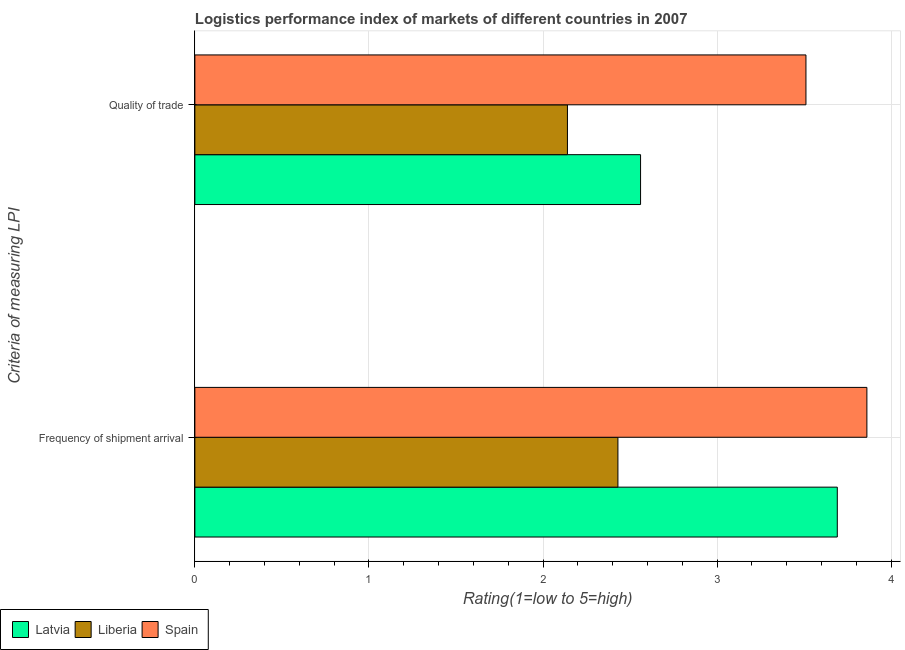How many groups of bars are there?
Keep it short and to the point. 2. Are the number of bars per tick equal to the number of legend labels?
Provide a succinct answer. Yes. Are the number of bars on each tick of the Y-axis equal?
Ensure brevity in your answer.  Yes. How many bars are there on the 1st tick from the bottom?
Make the answer very short. 3. What is the label of the 1st group of bars from the top?
Provide a succinct answer. Quality of trade. What is the lpi quality of trade in Liberia?
Ensure brevity in your answer.  2.14. Across all countries, what is the maximum lpi quality of trade?
Offer a terse response. 3.51. Across all countries, what is the minimum lpi quality of trade?
Provide a short and direct response. 2.14. In which country was the lpi of frequency of shipment arrival minimum?
Provide a short and direct response. Liberia. What is the total lpi of frequency of shipment arrival in the graph?
Make the answer very short. 9.98. What is the difference between the lpi of frequency of shipment arrival in Latvia and that in Spain?
Provide a short and direct response. -0.17. What is the difference between the lpi of frequency of shipment arrival in Latvia and the lpi quality of trade in Spain?
Offer a very short reply. 0.18. What is the average lpi quality of trade per country?
Your answer should be very brief. 2.74. What is the difference between the lpi of frequency of shipment arrival and lpi quality of trade in Spain?
Keep it short and to the point. 0.35. What is the ratio of the lpi quality of trade in Spain to that in Latvia?
Keep it short and to the point. 1.37. What does the 3rd bar from the top in Frequency of shipment arrival represents?
Offer a terse response. Latvia. What does the 3rd bar from the bottom in Quality of trade represents?
Offer a very short reply. Spain. Are all the bars in the graph horizontal?
Your answer should be very brief. Yes. How many countries are there in the graph?
Provide a short and direct response. 3. Are the values on the major ticks of X-axis written in scientific E-notation?
Provide a succinct answer. No. Does the graph contain any zero values?
Keep it short and to the point. No. Does the graph contain grids?
Your answer should be compact. Yes. How many legend labels are there?
Your response must be concise. 3. What is the title of the graph?
Your response must be concise. Logistics performance index of markets of different countries in 2007. What is the label or title of the X-axis?
Offer a very short reply. Rating(1=low to 5=high). What is the label or title of the Y-axis?
Keep it short and to the point. Criteria of measuring LPI. What is the Rating(1=low to 5=high) of Latvia in Frequency of shipment arrival?
Provide a succinct answer. 3.69. What is the Rating(1=low to 5=high) of Liberia in Frequency of shipment arrival?
Offer a very short reply. 2.43. What is the Rating(1=low to 5=high) in Spain in Frequency of shipment arrival?
Offer a terse response. 3.86. What is the Rating(1=low to 5=high) of Latvia in Quality of trade?
Provide a short and direct response. 2.56. What is the Rating(1=low to 5=high) in Liberia in Quality of trade?
Ensure brevity in your answer.  2.14. What is the Rating(1=low to 5=high) in Spain in Quality of trade?
Give a very brief answer. 3.51. Across all Criteria of measuring LPI, what is the maximum Rating(1=low to 5=high) of Latvia?
Your response must be concise. 3.69. Across all Criteria of measuring LPI, what is the maximum Rating(1=low to 5=high) of Liberia?
Your response must be concise. 2.43. Across all Criteria of measuring LPI, what is the maximum Rating(1=low to 5=high) of Spain?
Keep it short and to the point. 3.86. Across all Criteria of measuring LPI, what is the minimum Rating(1=low to 5=high) in Latvia?
Provide a succinct answer. 2.56. Across all Criteria of measuring LPI, what is the minimum Rating(1=low to 5=high) of Liberia?
Your response must be concise. 2.14. Across all Criteria of measuring LPI, what is the minimum Rating(1=low to 5=high) of Spain?
Provide a succinct answer. 3.51. What is the total Rating(1=low to 5=high) in Latvia in the graph?
Give a very brief answer. 6.25. What is the total Rating(1=low to 5=high) in Liberia in the graph?
Give a very brief answer. 4.57. What is the total Rating(1=low to 5=high) in Spain in the graph?
Provide a succinct answer. 7.37. What is the difference between the Rating(1=low to 5=high) of Latvia in Frequency of shipment arrival and that in Quality of trade?
Offer a terse response. 1.13. What is the difference between the Rating(1=low to 5=high) of Liberia in Frequency of shipment arrival and that in Quality of trade?
Your answer should be compact. 0.29. What is the difference between the Rating(1=low to 5=high) in Spain in Frequency of shipment arrival and that in Quality of trade?
Keep it short and to the point. 0.35. What is the difference between the Rating(1=low to 5=high) in Latvia in Frequency of shipment arrival and the Rating(1=low to 5=high) in Liberia in Quality of trade?
Your answer should be compact. 1.55. What is the difference between the Rating(1=low to 5=high) of Latvia in Frequency of shipment arrival and the Rating(1=low to 5=high) of Spain in Quality of trade?
Keep it short and to the point. 0.18. What is the difference between the Rating(1=low to 5=high) in Liberia in Frequency of shipment arrival and the Rating(1=low to 5=high) in Spain in Quality of trade?
Your answer should be very brief. -1.08. What is the average Rating(1=low to 5=high) of Latvia per Criteria of measuring LPI?
Offer a very short reply. 3.12. What is the average Rating(1=low to 5=high) in Liberia per Criteria of measuring LPI?
Provide a succinct answer. 2.29. What is the average Rating(1=low to 5=high) of Spain per Criteria of measuring LPI?
Your answer should be very brief. 3.69. What is the difference between the Rating(1=low to 5=high) of Latvia and Rating(1=low to 5=high) of Liberia in Frequency of shipment arrival?
Provide a succinct answer. 1.26. What is the difference between the Rating(1=low to 5=high) of Latvia and Rating(1=low to 5=high) of Spain in Frequency of shipment arrival?
Keep it short and to the point. -0.17. What is the difference between the Rating(1=low to 5=high) in Liberia and Rating(1=low to 5=high) in Spain in Frequency of shipment arrival?
Provide a succinct answer. -1.43. What is the difference between the Rating(1=low to 5=high) in Latvia and Rating(1=low to 5=high) in Liberia in Quality of trade?
Ensure brevity in your answer.  0.42. What is the difference between the Rating(1=low to 5=high) of Latvia and Rating(1=low to 5=high) of Spain in Quality of trade?
Your answer should be very brief. -0.95. What is the difference between the Rating(1=low to 5=high) in Liberia and Rating(1=low to 5=high) in Spain in Quality of trade?
Provide a short and direct response. -1.37. What is the ratio of the Rating(1=low to 5=high) of Latvia in Frequency of shipment arrival to that in Quality of trade?
Keep it short and to the point. 1.44. What is the ratio of the Rating(1=low to 5=high) in Liberia in Frequency of shipment arrival to that in Quality of trade?
Offer a very short reply. 1.14. What is the ratio of the Rating(1=low to 5=high) of Spain in Frequency of shipment arrival to that in Quality of trade?
Provide a short and direct response. 1.1. What is the difference between the highest and the second highest Rating(1=low to 5=high) of Latvia?
Your response must be concise. 1.13. What is the difference between the highest and the second highest Rating(1=low to 5=high) in Liberia?
Ensure brevity in your answer.  0.29. What is the difference between the highest and the second highest Rating(1=low to 5=high) in Spain?
Your answer should be very brief. 0.35. What is the difference between the highest and the lowest Rating(1=low to 5=high) in Latvia?
Provide a succinct answer. 1.13. What is the difference between the highest and the lowest Rating(1=low to 5=high) of Liberia?
Provide a succinct answer. 0.29. 